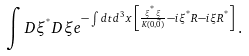<formula> <loc_0><loc_0><loc_500><loc_500>\int D \xi ^ { ^ { * } } D \xi e ^ { - \int d t d ^ { 3 } x \, \left [ \frac { \xi ^ { ^ { * } } \xi } { K ( 0 , \vec { 0 } ) } - i \xi ^ { ^ { * } } R - i \xi R ^ { ^ { * } } \right ] } \, .</formula> 